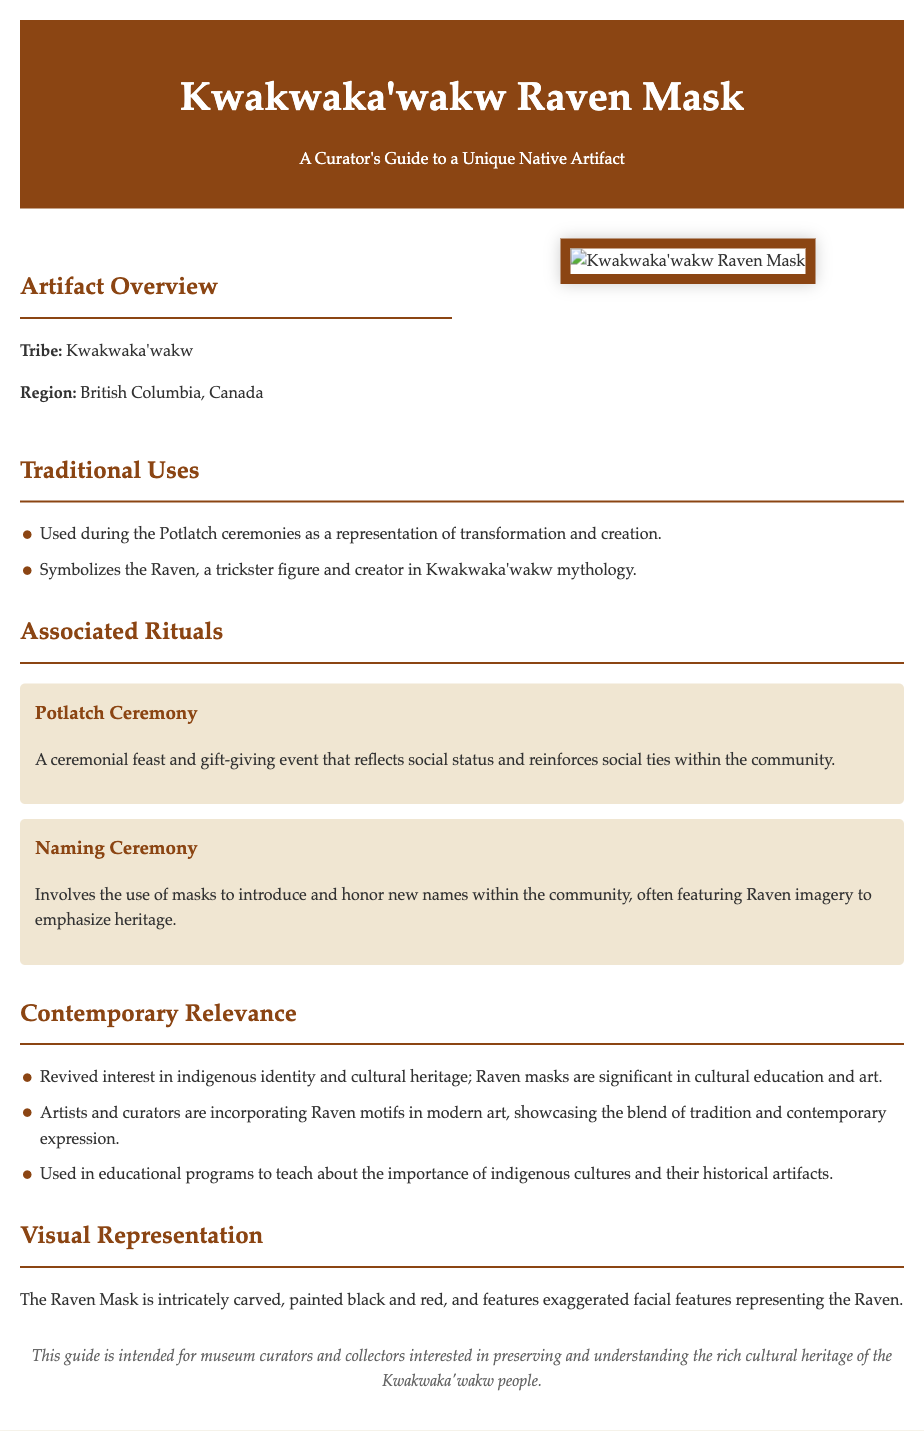What tribe is the Raven Mask associated with? The document explicitly states the tribe associated with the Raven Mask as Kwakwaka'wakw.
Answer: Kwakwaka'wakw What region does the Kwakwaka'wakw tribe inhabit? The document mentions that the Kwakwaka'wakw tribe is located in British Columbia, Canada.
Answer: British Columbia, Canada What ceremonial event prominently uses the Raven Mask? The text identifies the Potlatch ceremony as a key event in which the Raven Mask is used.
Answer: Potlatch ceremony What is one of the main functions of the Potlatch ceremony? The document describes the Potlatch ceremony as a reflection of social status and reinforcement of social ties within the community.
Answer: Reflects social status What colors are used in the painting of the Raven Mask? The document notes that the Raven Mask is painted black and red.
Answer: Black and red How are Raven masks relevant to contemporary culture? The text outlines that there is a revived interest in indigenous identity and cultural heritage, marking the relevance of Raven masks today.
Answer: Revived interest in indigenous identity What type of ceremony involves honoring new names in the community? The document references the Naming Ceremony as one that involves honoring new names.
Answer: Naming Ceremony What visual characteristics define the Raven Mask? According to the document, the Raven Mask features exaggerated facial features representing the Raven.
Answer: Exaggerated facial features What type of document is this? The document is designed as a guide for museum curators and collectors regarding a unique native artifact.
Answer: A curator's guide 